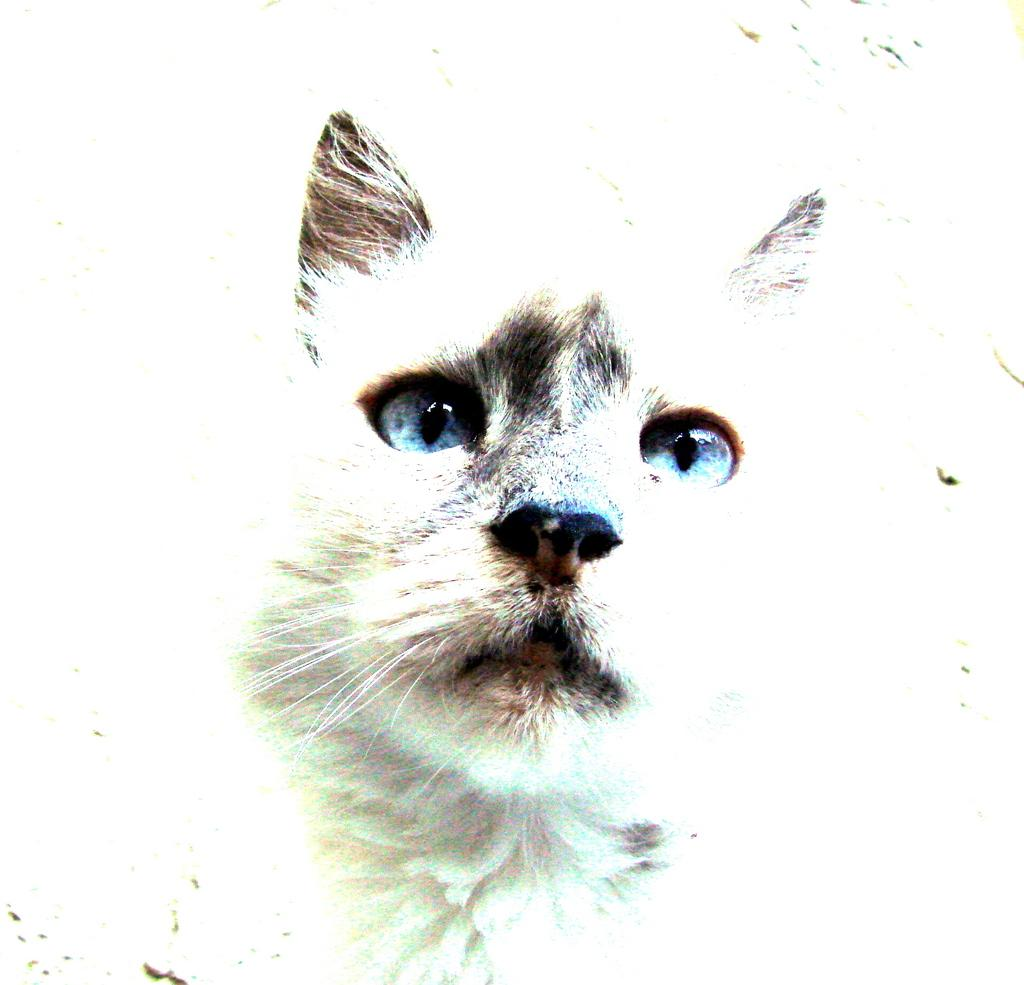What type of creature can be seen in the image? There is an animal in the image. Can you describe the background of the image? The background of the image is bright. What level of difficulty is the beginner's guide to coughing in the image? There is no guide or reference to coughing in the image; it features an animal and a bright background. 